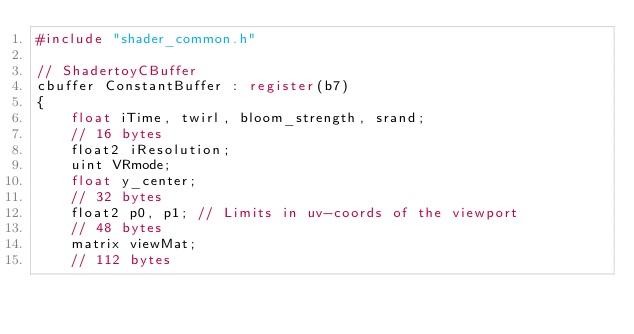Convert code to text. <code><loc_0><loc_0><loc_500><loc_500><_C_>#include "shader_common.h"

// ShadertoyCBuffer
cbuffer ConstantBuffer : register(b7)
{
	float iTime, twirl, bloom_strength, srand;
	// 16 bytes
	float2 iResolution;
	uint VRmode;
	float y_center;
	// 32 bytes
	float2 p0, p1; // Limits in uv-coords of the viewport
	// 48 bytes
	matrix viewMat;
	// 112 bytes</code> 